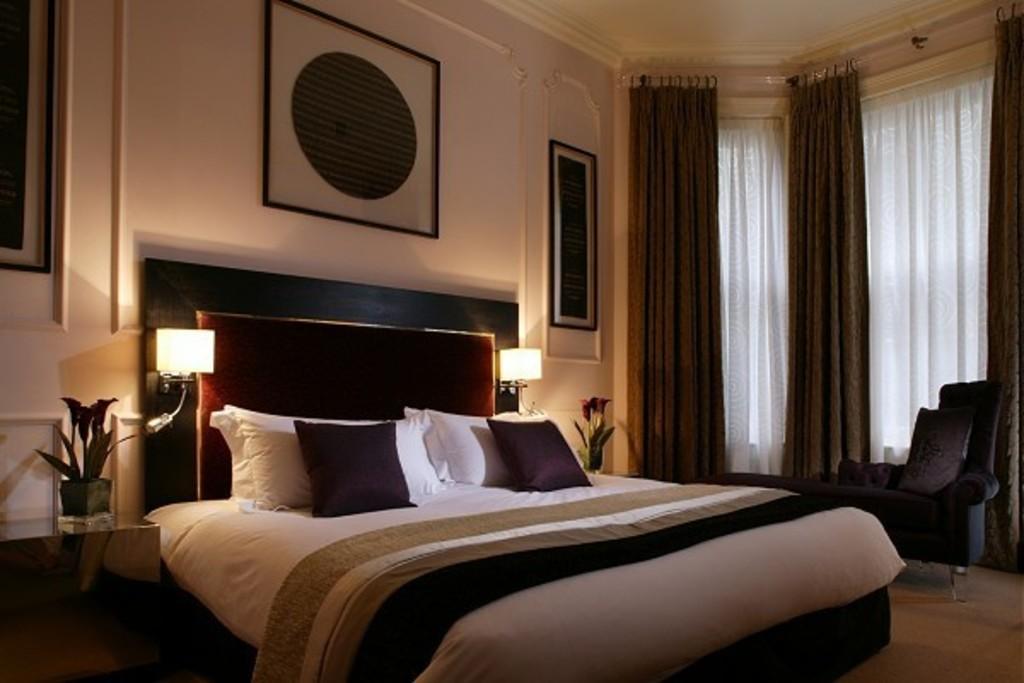Describe this image in one or two sentences. In this picture we can see a few pillows on the bed. There is a blanket. We can see flower pots and lamps on the right and left side of the bed. There are few frames on the wall. We can see curtains and a chair on the right side. 